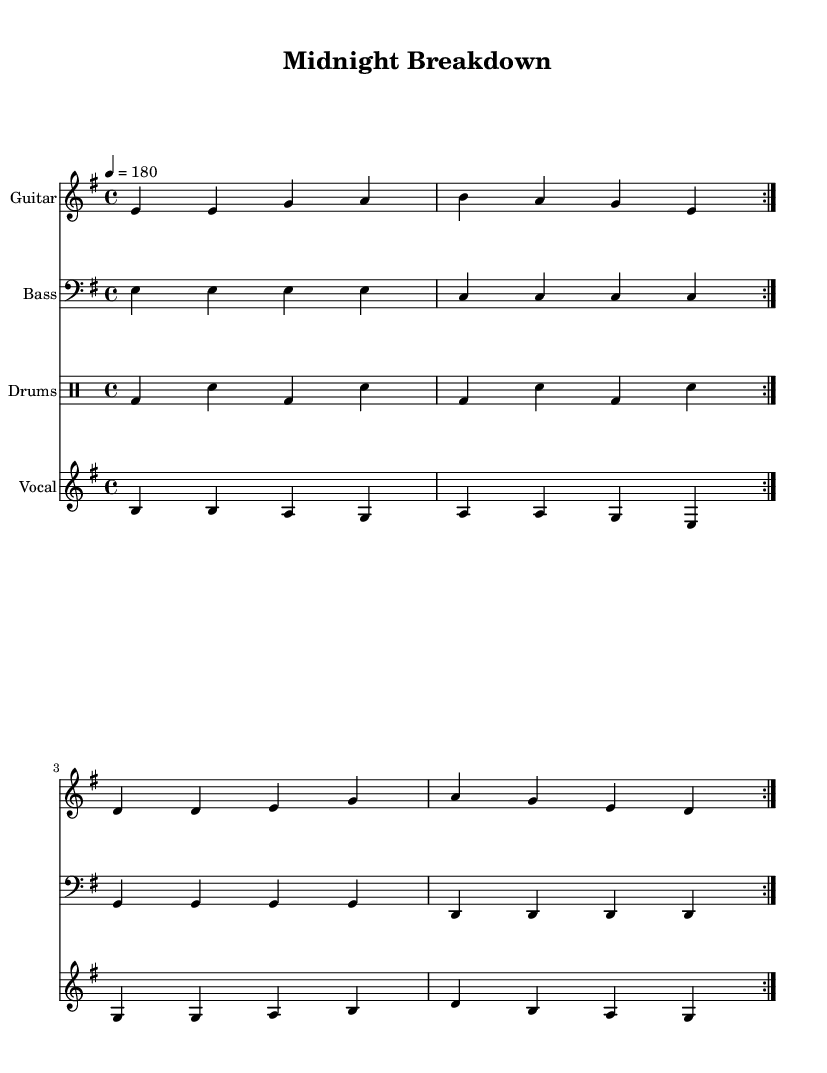What is the key signature of this music? The key signature indicated in the music is E minor, which has one sharp (F#). This can be identified from the global section that specifies the key.
Answer: E minor What is the time signature of this music? The time signature shown in the music is 4/4, meaning there are four beats in each measure and a quarter note receives one beat. This is outlined in the global section.
Answer: 4/4 What is the tempo of the piece? The tempo is set at 180 beats per minute as indicated in the musical notations within the global section. This shows how fast the music is meant to be played.
Answer: 180 How many measures are in the repeating sections for guitar and bass? Both the guitar and bass parts have two repeated measures as stated with the 'repeat volta 2' instruction, which tells performers to play those measures twice before moving on.
Answer: 2 What are the first lyrics of the verse? The first lyrics of the verse provided under the vocal staff are "Mid -- night call, bro -- ken down car." These lyrics are explicitly shown in the vocal part along with its linking to the music.
Answer: Mid -- night call, bro -- ken down car What is the main theme of the lyrics? The main theme of the lyrics revolves around late-night car troubles and the experience of stranded motorists waiting for assistance, reflecting the essence of punk rock's gritty storytelling. This can be deduced from the verse and chorus lyrics provided.
Answer: Late-night car troubles How is the vocal melody described? The vocal melody has a range of pitches including B, A, G, and D throughout the repeated sections. This can be observed in the relative note values notated for the melody.
Answer: Varied pitches (B, A, G, D) 